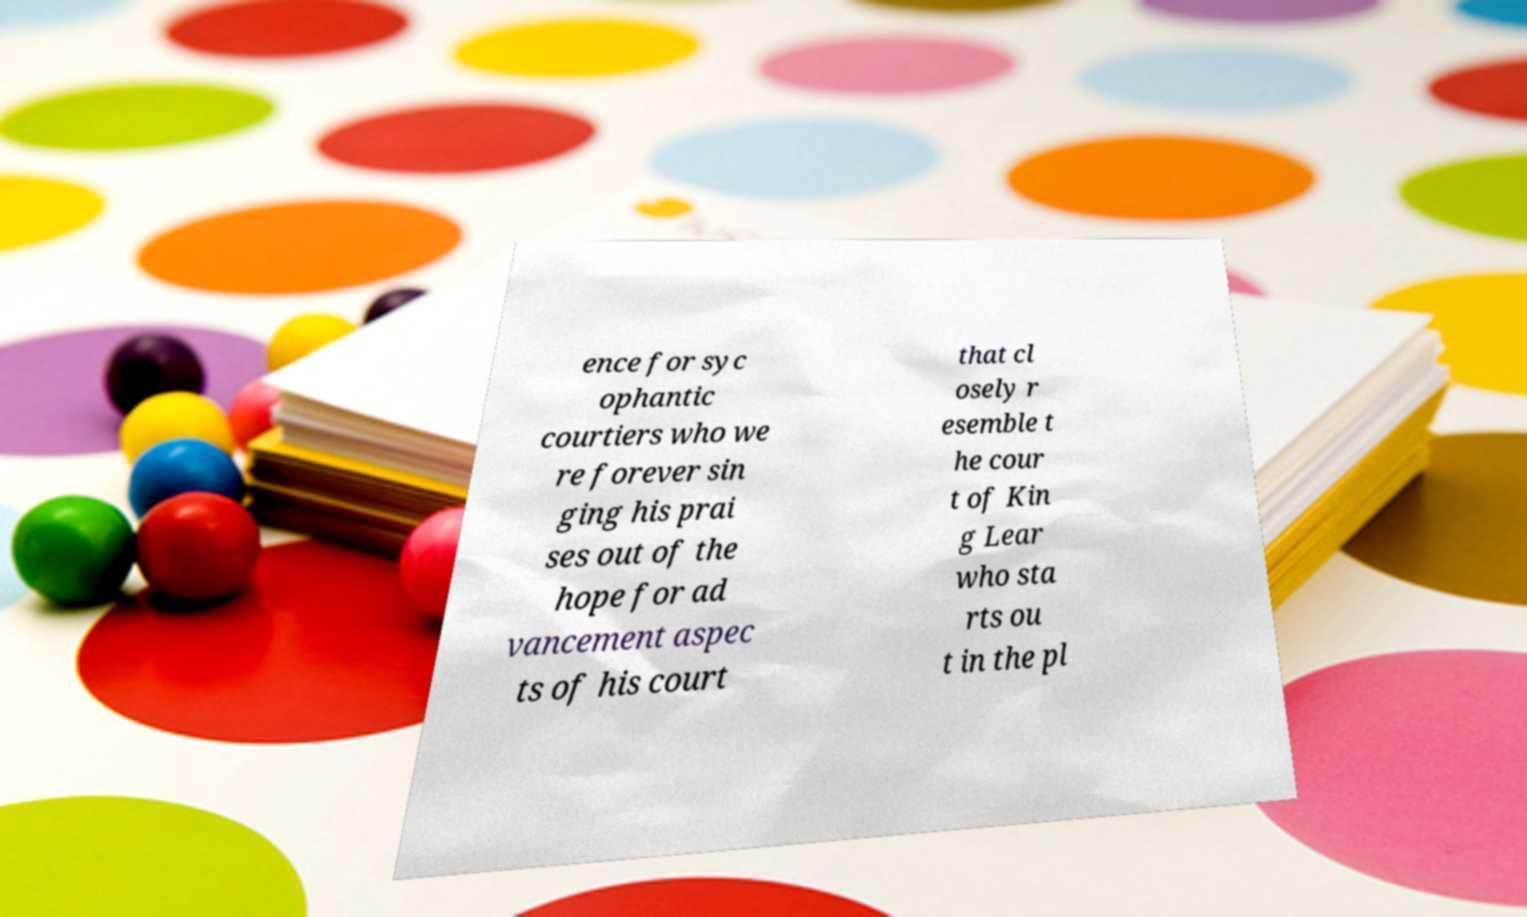Can you read and provide the text displayed in the image?This photo seems to have some interesting text. Can you extract and type it out for me? ence for syc ophantic courtiers who we re forever sin ging his prai ses out of the hope for ad vancement aspec ts of his court that cl osely r esemble t he cour t of Kin g Lear who sta rts ou t in the pl 